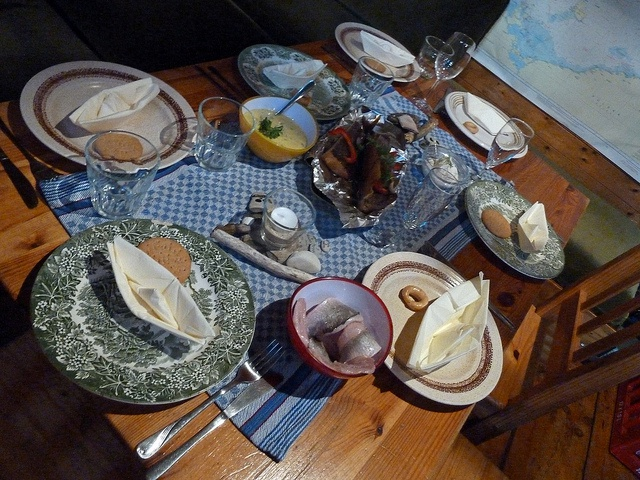Describe the objects in this image and their specific colors. I can see dining table in black, gray, darkgray, and brown tones, chair in black, maroon, and brown tones, bowl in black, gray, darkgray, and maroon tones, cup in black, gray, and darkgray tones, and bowl in black, olive, and gray tones in this image. 